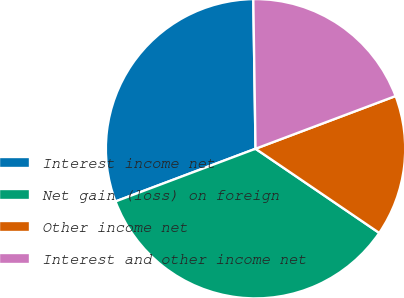Convert chart to OTSL. <chart><loc_0><loc_0><loc_500><loc_500><pie_chart><fcel>Interest income net<fcel>Net gain (loss) on foreign<fcel>Other income net<fcel>Interest and other income net<nl><fcel>30.49%<fcel>34.76%<fcel>15.24%<fcel>19.51%<nl></chart> 